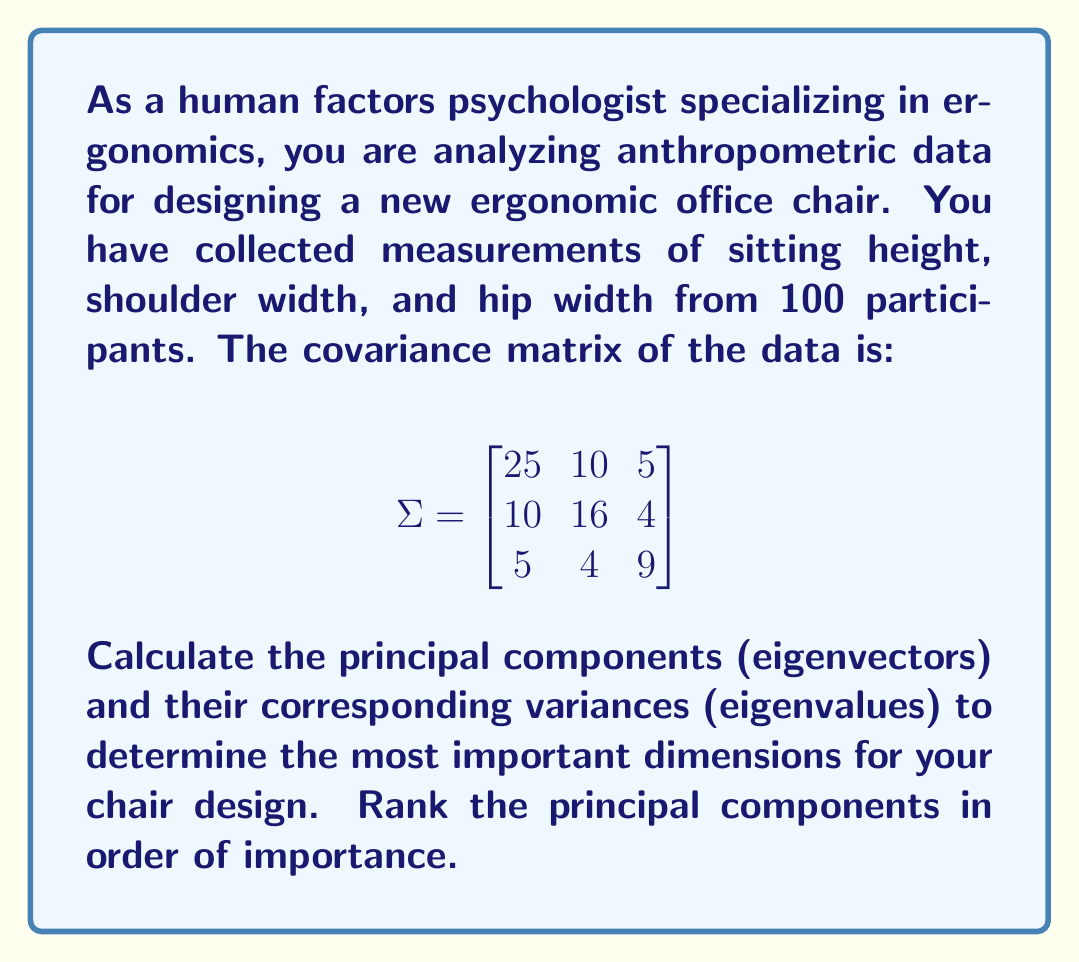Teach me how to tackle this problem. To find the principal components and their variances, we need to perform eigendecomposition on the covariance matrix $\Sigma$.

Step 1: Set up the characteristic equation:
$$\det(\Sigma - \lambda I) = 0$$

Step 2: Expand the determinant:
$$\begin{vmatrix}
25-\lambda & 10 & 5 \\
10 & 16-\lambda & 4 \\
5 & 4 & 9-\lambda
\end{vmatrix} = 0$$

Step 3: Solve the characteristic equation:
$$(25-\lambda)(16-\lambda)(9-\lambda) - 10^2(9-\lambda) - 5^2(16-\lambda) - 4^2(25-\lambda) + 2(10)(5)(4) = 0$$

This yields the cubic equation:
$$-\lambda^3 + 50\lambda^2 - 659\lambda + 2000 = 0$$

Step 4: Find the eigenvalues (λ):
Using a numerical method or calculator, we get:
$\lambda_1 \approx 36.84$, $\lambda_2 \approx 10.98$, $\lambda_3 \approx 2.18$

Step 5: Find the eigenvectors for each eigenvalue:
For $\lambda_1 \approx 36.84$:
$$(\Sigma - 36.84I)\mathbf{v_1} = \mathbf{0}$$
Solving this system gives us: $\mathbf{v_1} \approx [0.707, 0.636, 0.309]^T$

For $\lambda_2 \approx 10.98$:
$$(\Sigma - 10.98I)\mathbf{v_2} = \mathbf{0}$$
Solving this system gives us: $\mathbf{v_2} \approx [-0.303, 0.539, -0.786]^T$

For $\lambda_3 \approx 2.18$:
$$(\Sigma - 2.18I)\mathbf{v_3} = \mathbf{0}$$
Solving this system gives us: $\mathbf{v_3} \approx [0.640, -0.552, -0.535]^T$

Step 6: Rank the principal components:
1. $\mathbf{v_1}$ (variance = 36.84): [0.707, 0.636, 0.309]
2. $\mathbf{v_2}$ (variance = 10.98): [-0.303, 0.539, -0.786]
3. $\mathbf{v_3}$ (variance = 2.18): [0.640, -0.552, -0.535]
Answer: Principal components (eigenvectors) in order of importance:
1. [0.707, 0.636, 0.309]
2. [-0.303, 0.539, -0.786]
3. [0.640, -0.552, -0.535]
Corresponding variances (eigenvalues):
36.84, 10.98, 2.18 